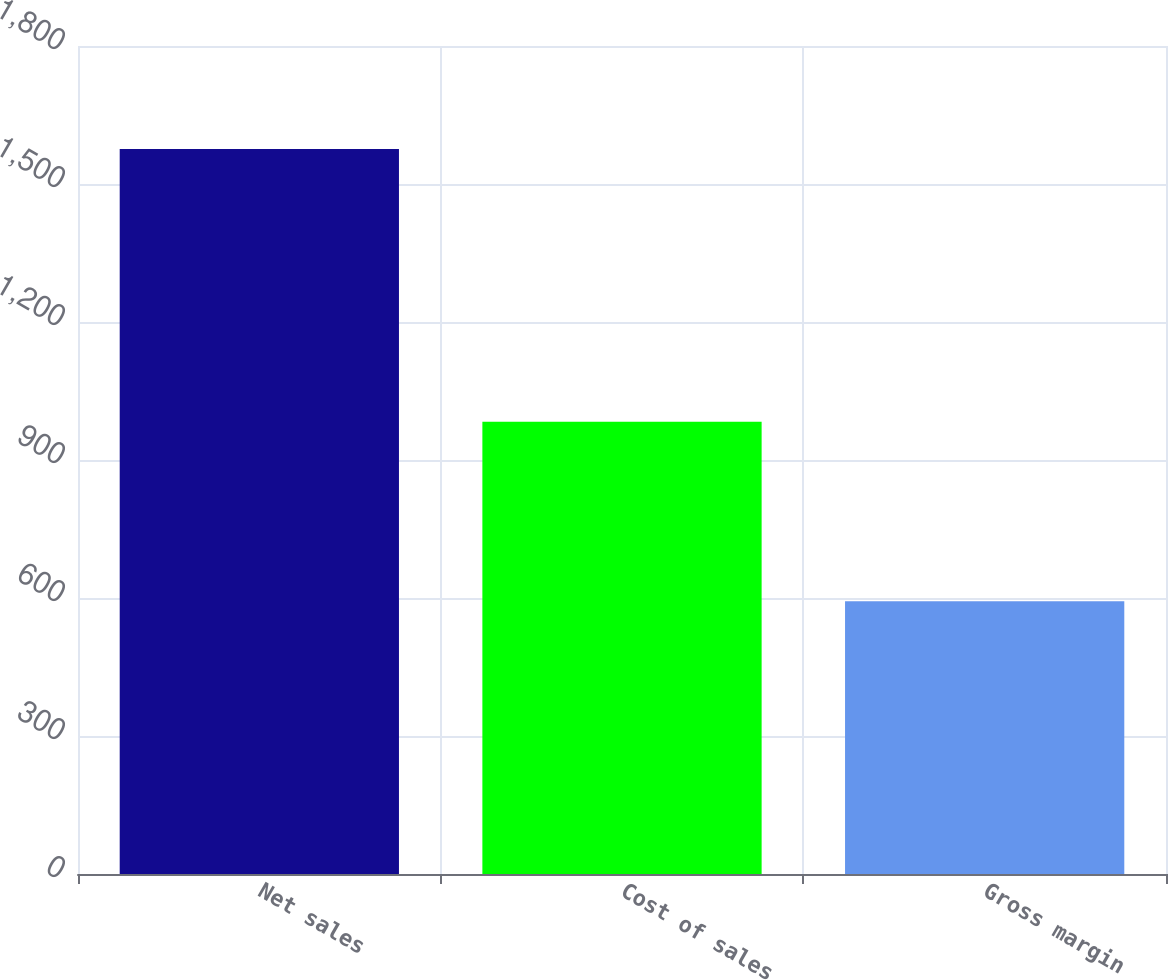Convert chart. <chart><loc_0><loc_0><loc_500><loc_500><bar_chart><fcel>Net sales<fcel>Cost of sales<fcel>Gross margin<nl><fcel>1576.3<fcel>983.2<fcel>593.1<nl></chart> 